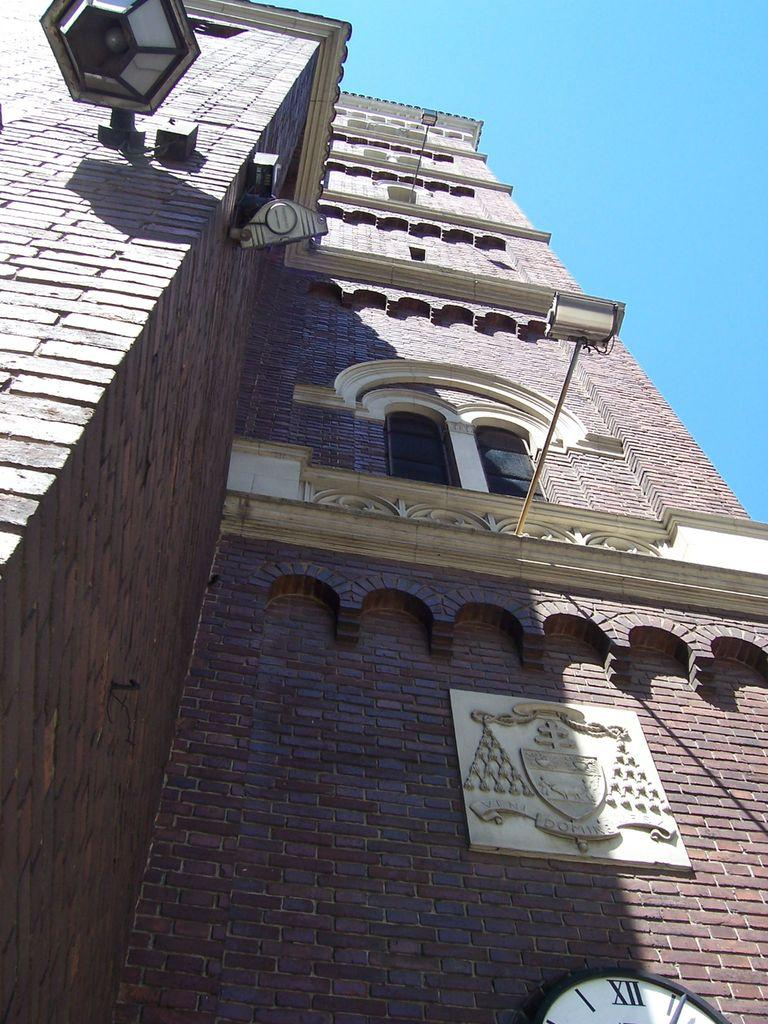What is located in the foreground of the image? There is a building wall, a window, and a lamp in the foreground of the image. What is mounted on the building wall? A clock is mounted on the building wall. What is the color of the sky in the image? The sky is blue and visible in the image. When was the image likely taken? The image was taken during the day. Can you see a stranger holding a rose in the image? There is no stranger or rose present in the image. Is there any eggnog visible in the image? There is no eggnog present in the image. 